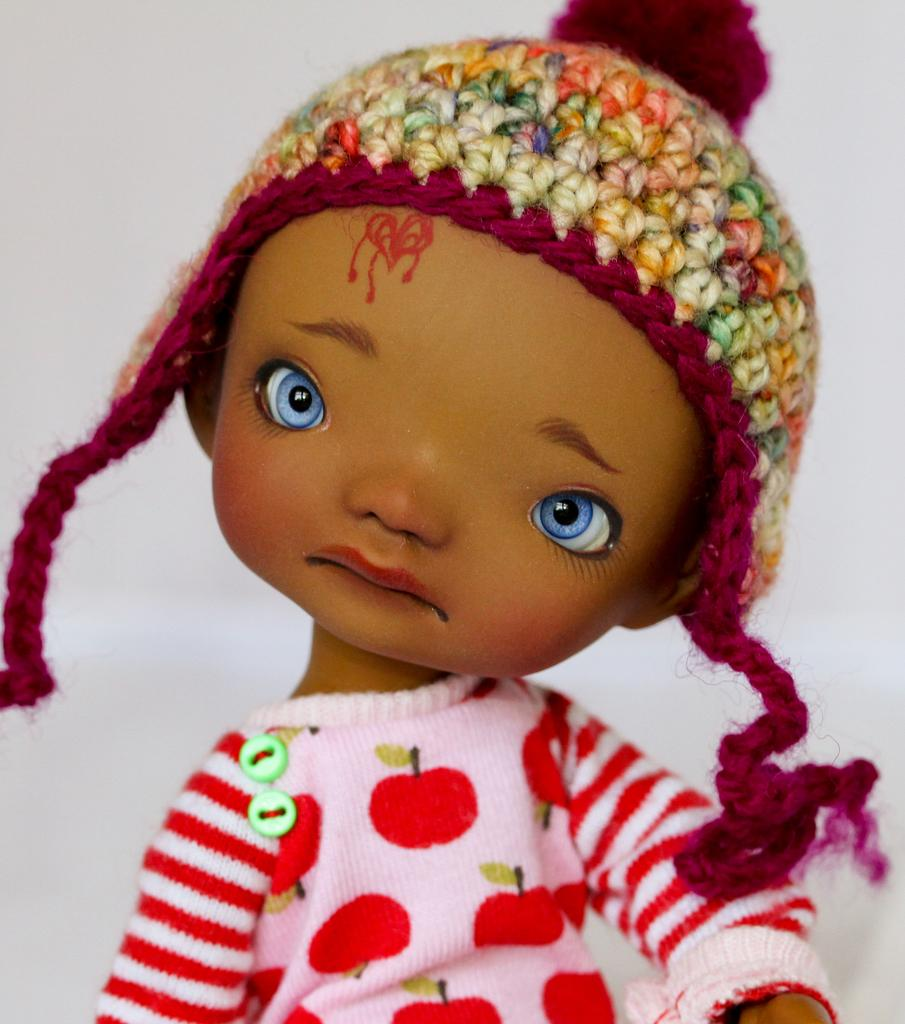What can you describe the toy in the image? There is a toy in the image, but the specific details are not mentioned in the provided facts. What is on the head in the image? There is a cap on the head in the image. What color is the background of the image? The background of the image is white. What type of steel structure can be seen in the image? There is no steel structure present in the image. What is the oven used for in the image? There is no oven present in the image. 